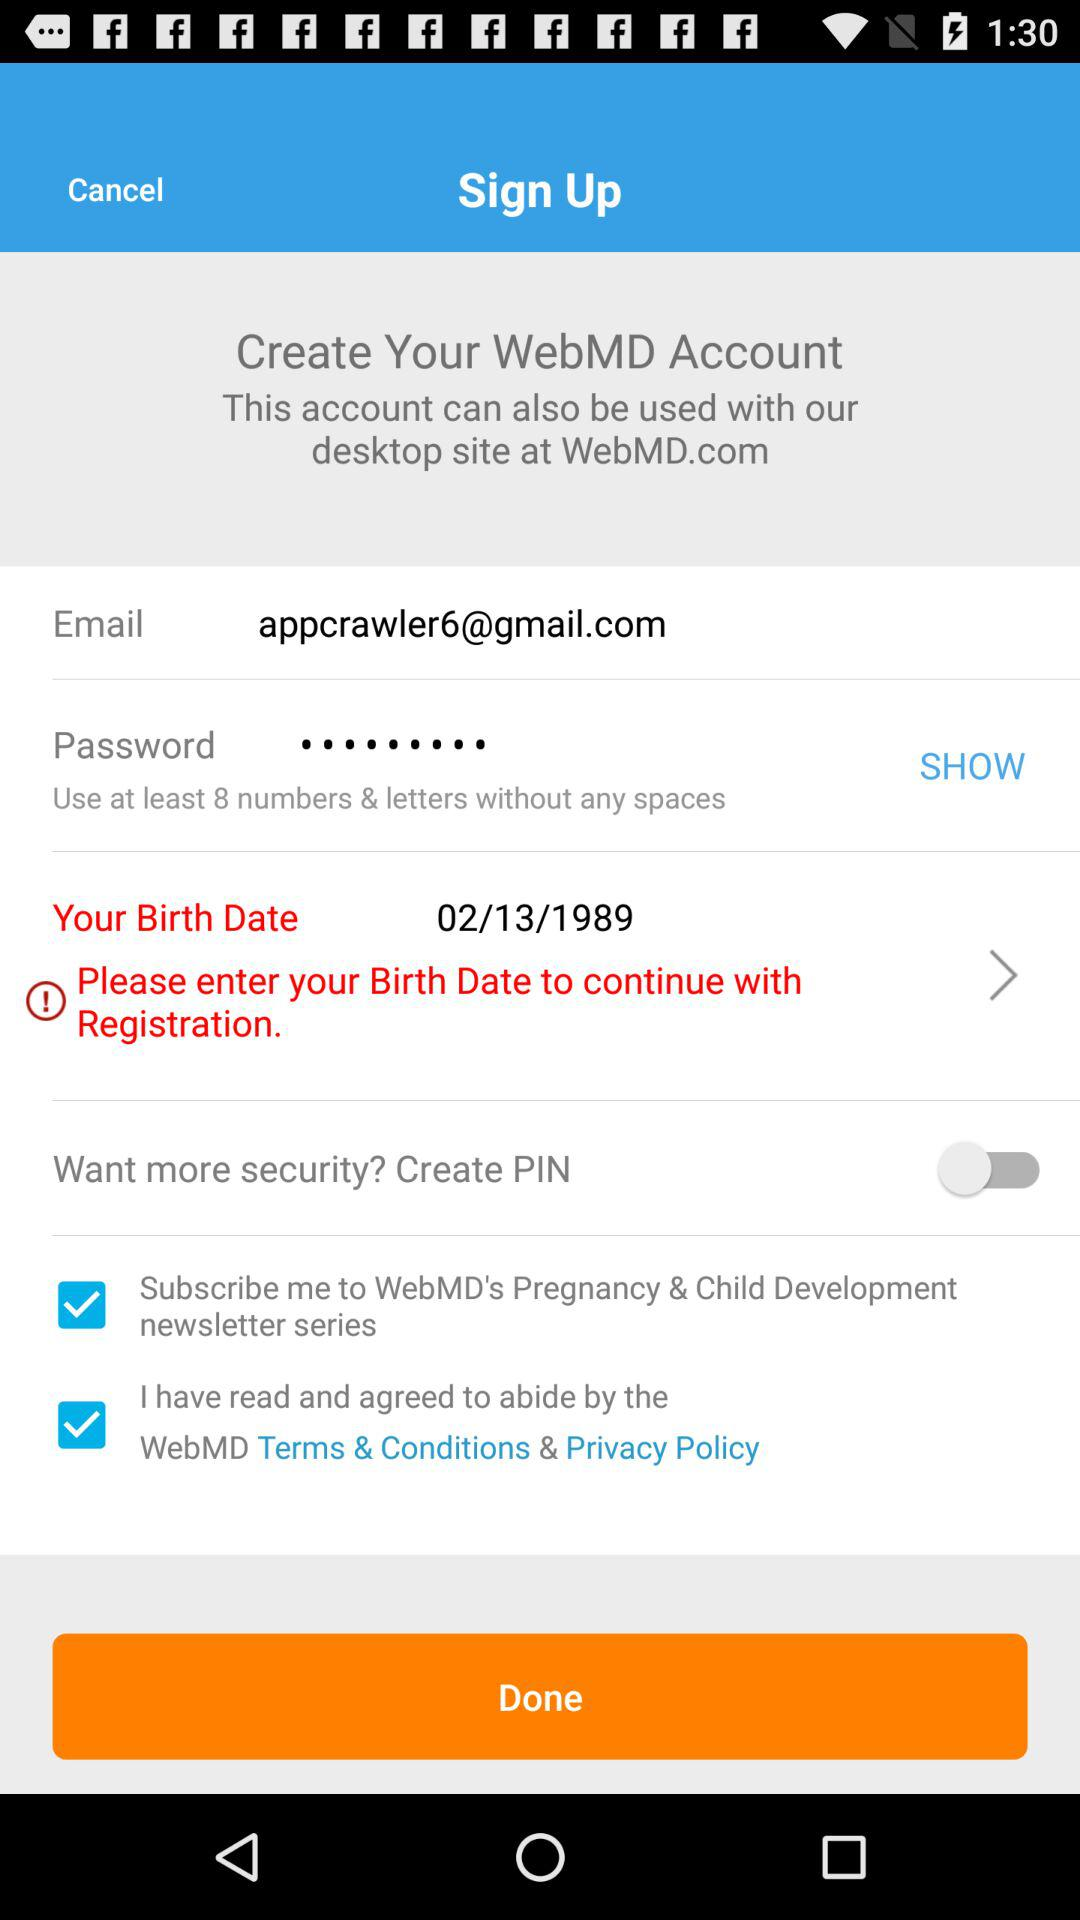What is the email address? The email address is appcrawler6@gmail.com. 